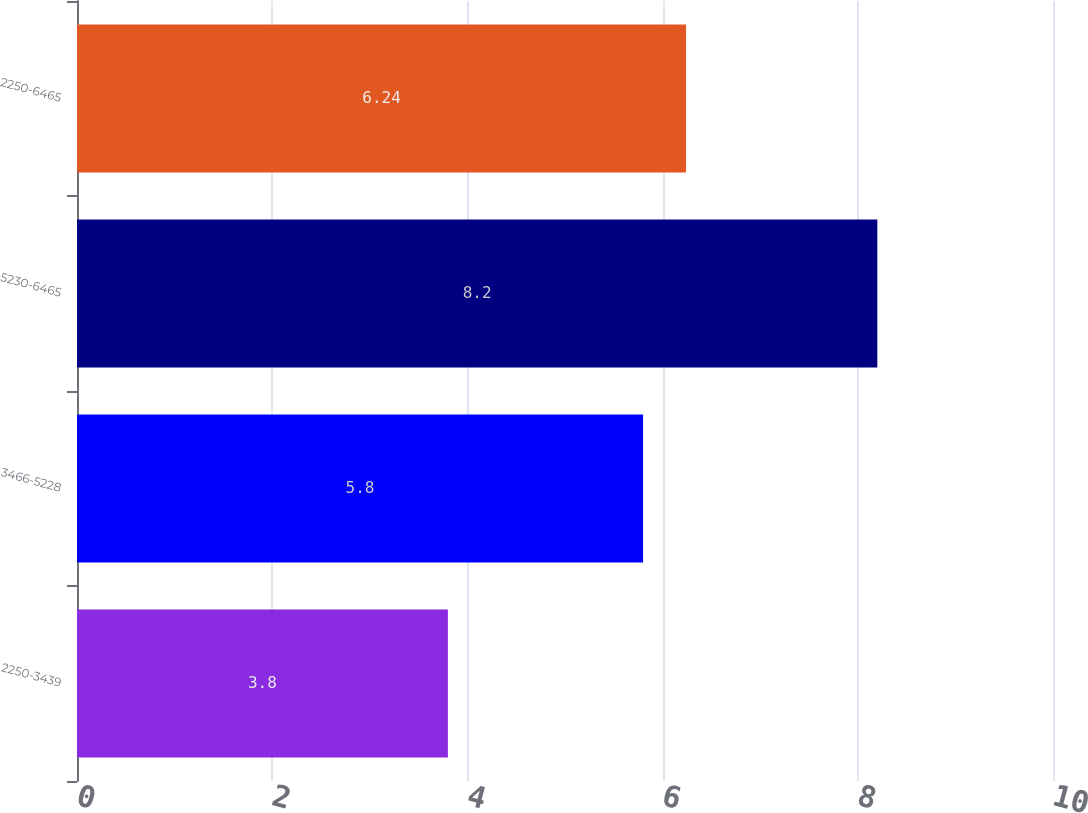Convert chart. <chart><loc_0><loc_0><loc_500><loc_500><bar_chart><fcel>2250-3439<fcel>3466-5228<fcel>5230-6465<fcel>2250-6465<nl><fcel>3.8<fcel>5.8<fcel>8.2<fcel>6.24<nl></chart> 